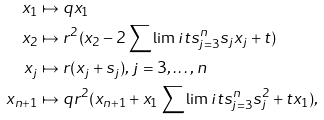<formula> <loc_0><loc_0><loc_500><loc_500>x _ { 1 } & \mapsto q x _ { 1 } \\ x _ { 2 } & \mapsto r ^ { 2 } ( x _ { 2 } - 2 \sum \lim i t s _ { j = 3 } ^ { n } s _ { j } x _ { j } + t ) \\ x _ { j } & \mapsto r ( x _ { j } + s _ { j } ) , \, j = 3 , \dots , n \\ x _ { n + 1 } & \mapsto q r ^ { 2 } ( x _ { n + 1 } + x _ { 1 } \sum \lim i t s _ { j = 3 } ^ { n } s _ { j } ^ { 2 } + t x _ { 1 } ) ,</formula> 